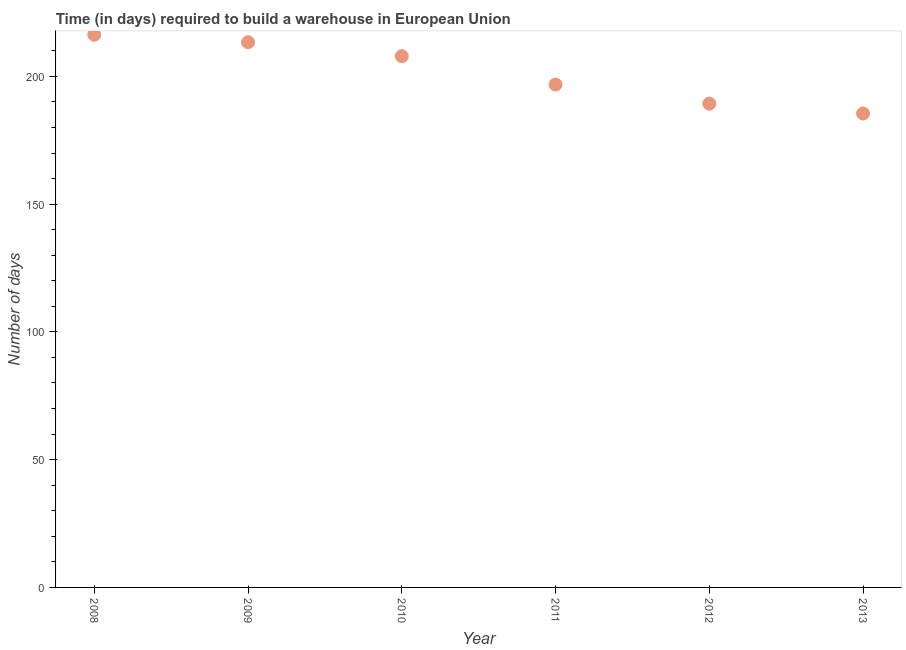What is the time required to build a warehouse in 2009?
Make the answer very short. 213.35. Across all years, what is the maximum time required to build a warehouse?
Provide a short and direct response. 216.28. Across all years, what is the minimum time required to build a warehouse?
Ensure brevity in your answer.  185.46. In which year was the time required to build a warehouse maximum?
Your answer should be compact. 2008. What is the sum of the time required to build a warehouse?
Provide a short and direct response. 1209.09. What is the difference between the time required to build a warehouse in 2012 and 2013?
Offer a terse response. 3.86. What is the average time required to build a warehouse per year?
Make the answer very short. 201.51. What is the median time required to build a warehouse?
Your answer should be very brief. 202.34. In how many years, is the time required to build a warehouse greater than 20 days?
Offer a very short reply. 6. What is the ratio of the time required to build a warehouse in 2008 to that in 2009?
Your answer should be compact. 1.01. What is the difference between the highest and the second highest time required to build a warehouse?
Your answer should be very brief. 2.93. Is the sum of the time required to build a warehouse in 2009 and 2011 greater than the maximum time required to build a warehouse across all years?
Your answer should be compact. Yes. What is the difference between the highest and the lowest time required to build a warehouse?
Offer a very short reply. 30.81. Does the time required to build a warehouse monotonically increase over the years?
Your response must be concise. No. What is the difference between two consecutive major ticks on the Y-axis?
Your response must be concise. 50. Are the values on the major ticks of Y-axis written in scientific E-notation?
Provide a succinct answer. No. Does the graph contain any zero values?
Provide a short and direct response. No. What is the title of the graph?
Ensure brevity in your answer.  Time (in days) required to build a warehouse in European Union. What is the label or title of the X-axis?
Give a very brief answer. Year. What is the label or title of the Y-axis?
Ensure brevity in your answer.  Number of days. What is the Number of days in 2008?
Provide a succinct answer. 216.28. What is the Number of days in 2009?
Keep it short and to the point. 213.35. What is the Number of days in 2010?
Give a very brief answer. 207.89. What is the Number of days in 2011?
Provide a short and direct response. 196.79. What is the Number of days in 2012?
Offer a terse response. 189.32. What is the Number of days in 2013?
Your answer should be very brief. 185.46. What is the difference between the Number of days in 2008 and 2009?
Ensure brevity in your answer.  2.93. What is the difference between the Number of days in 2008 and 2010?
Provide a succinct answer. 8.39. What is the difference between the Number of days in 2008 and 2011?
Your answer should be very brief. 19.49. What is the difference between the Number of days in 2008 and 2012?
Give a very brief answer. 26.96. What is the difference between the Number of days in 2008 and 2013?
Provide a short and direct response. 30.81. What is the difference between the Number of days in 2009 and 2010?
Provide a succinct answer. 5.46. What is the difference between the Number of days in 2009 and 2011?
Provide a succinct answer. 16.57. What is the difference between the Number of days in 2009 and 2012?
Keep it short and to the point. 24.03. What is the difference between the Number of days in 2009 and 2013?
Offer a terse response. 27.89. What is the difference between the Number of days in 2010 and 2011?
Provide a succinct answer. 11.1. What is the difference between the Number of days in 2010 and 2012?
Make the answer very short. 18.57. What is the difference between the Number of days in 2010 and 2013?
Your response must be concise. 22.42. What is the difference between the Number of days in 2011 and 2012?
Provide a succinct answer. 7.46. What is the difference between the Number of days in 2011 and 2013?
Your response must be concise. 11.32. What is the difference between the Number of days in 2012 and 2013?
Make the answer very short. 3.86. What is the ratio of the Number of days in 2008 to that in 2010?
Keep it short and to the point. 1.04. What is the ratio of the Number of days in 2008 to that in 2011?
Keep it short and to the point. 1.1. What is the ratio of the Number of days in 2008 to that in 2012?
Give a very brief answer. 1.14. What is the ratio of the Number of days in 2008 to that in 2013?
Offer a terse response. 1.17. What is the ratio of the Number of days in 2009 to that in 2011?
Offer a terse response. 1.08. What is the ratio of the Number of days in 2009 to that in 2012?
Provide a succinct answer. 1.13. What is the ratio of the Number of days in 2009 to that in 2013?
Your response must be concise. 1.15. What is the ratio of the Number of days in 2010 to that in 2011?
Give a very brief answer. 1.06. What is the ratio of the Number of days in 2010 to that in 2012?
Give a very brief answer. 1.1. What is the ratio of the Number of days in 2010 to that in 2013?
Provide a succinct answer. 1.12. What is the ratio of the Number of days in 2011 to that in 2012?
Provide a short and direct response. 1.04. What is the ratio of the Number of days in 2011 to that in 2013?
Offer a terse response. 1.06. What is the ratio of the Number of days in 2012 to that in 2013?
Your answer should be very brief. 1.02. 